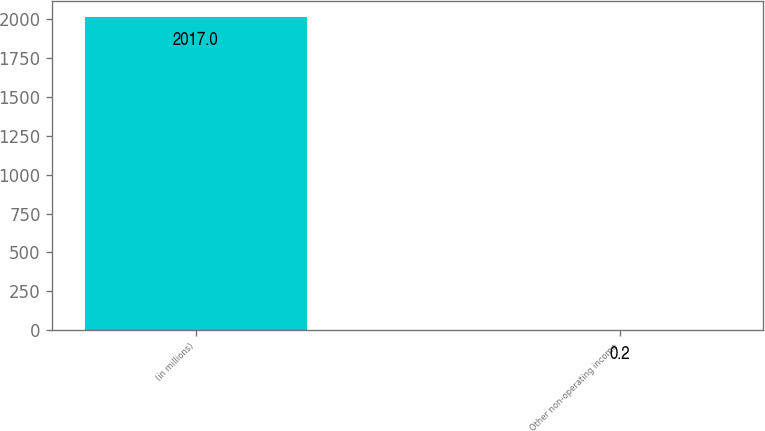<chart> <loc_0><loc_0><loc_500><loc_500><bar_chart><fcel>(in millions)<fcel>Other non-operating income<nl><fcel>2017<fcel>0.2<nl></chart> 